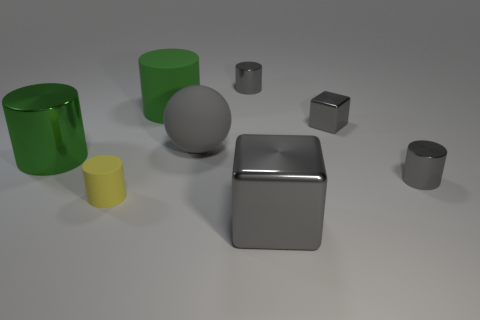Subtract all cyan cylinders. Subtract all red cubes. How many cylinders are left? 5 Add 1 tiny yellow things. How many objects exist? 9 Subtract all balls. How many objects are left? 7 Subtract 2 green cylinders. How many objects are left? 6 Subtract all big balls. Subtract all large green rubber cylinders. How many objects are left? 6 Add 5 tiny gray shiny objects. How many tiny gray shiny objects are left? 8 Add 5 small gray rubber things. How many small gray rubber things exist? 5 